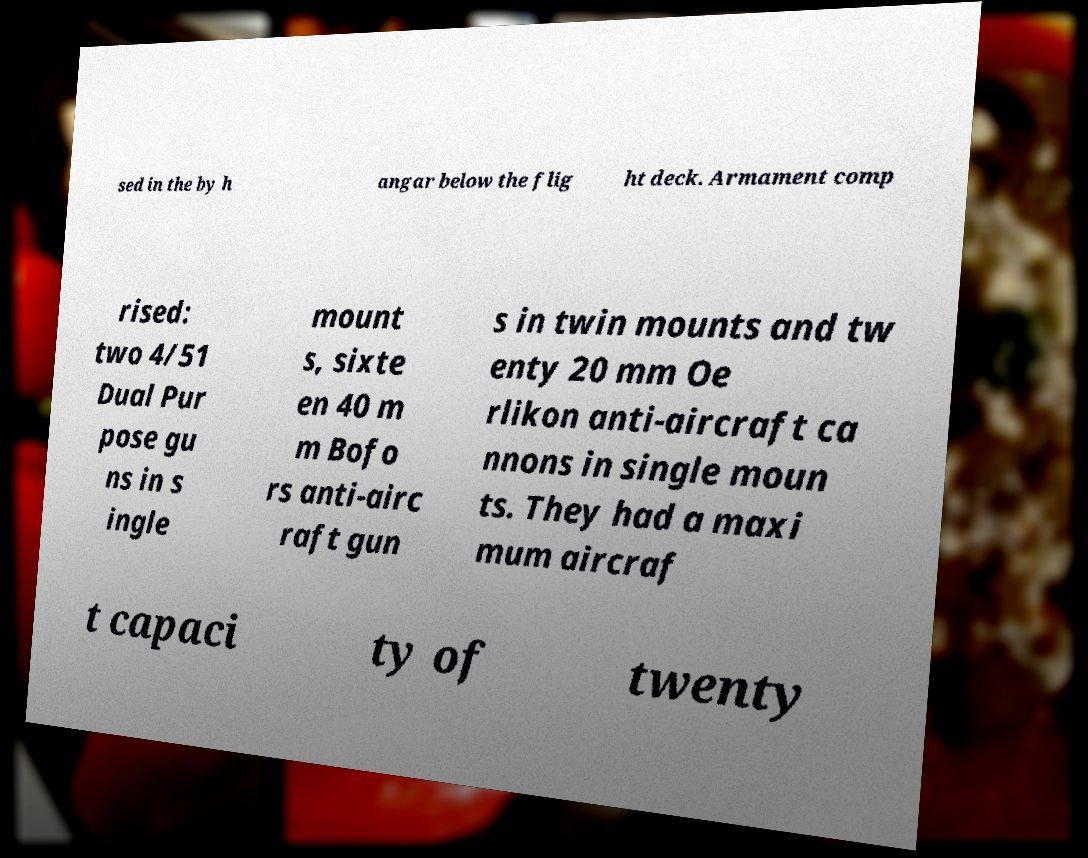Please identify and transcribe the text found in this image. sed in the by h angar below the flig ht deck. Armament comp rised: two 4/51 Dual Pur pose gu ns in s ingle mount s, sixte en 40 m m Bofo rs anti-airc raft gun s in twin mounts and tw enty 20 mm Oe rlikon anti-aircraft ca nnons in single moun ts. They had a maxi mum aircraf t capaci ty of twenty 